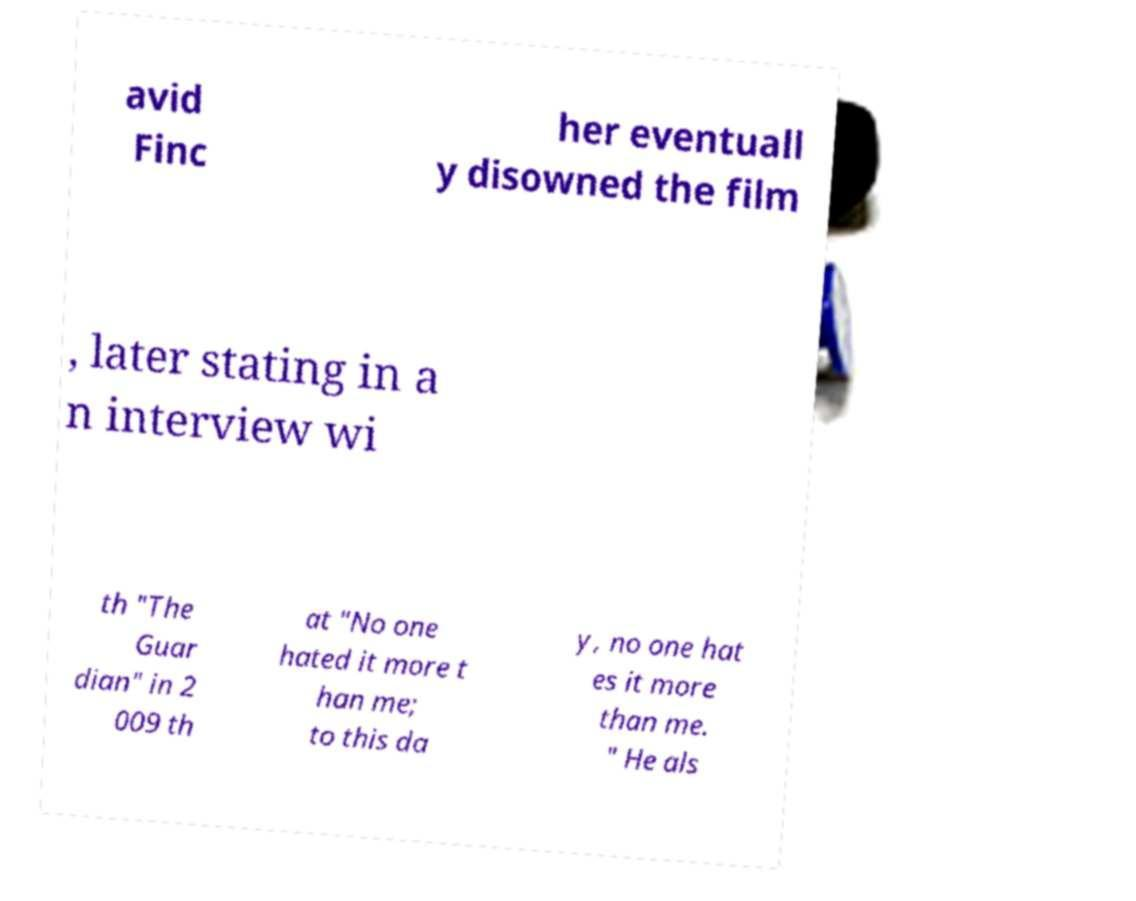Can you read and provide the text displayed in the image?This photo seems to have some interesting text. Can you extract and type it out for me? avid Finc her eventuall y disowned the film , later stating in a n interview wi th "The Guar dian" in 2 009 th at "No one hated it more t han me; to this da y, no one hat es it more than me. " He als 